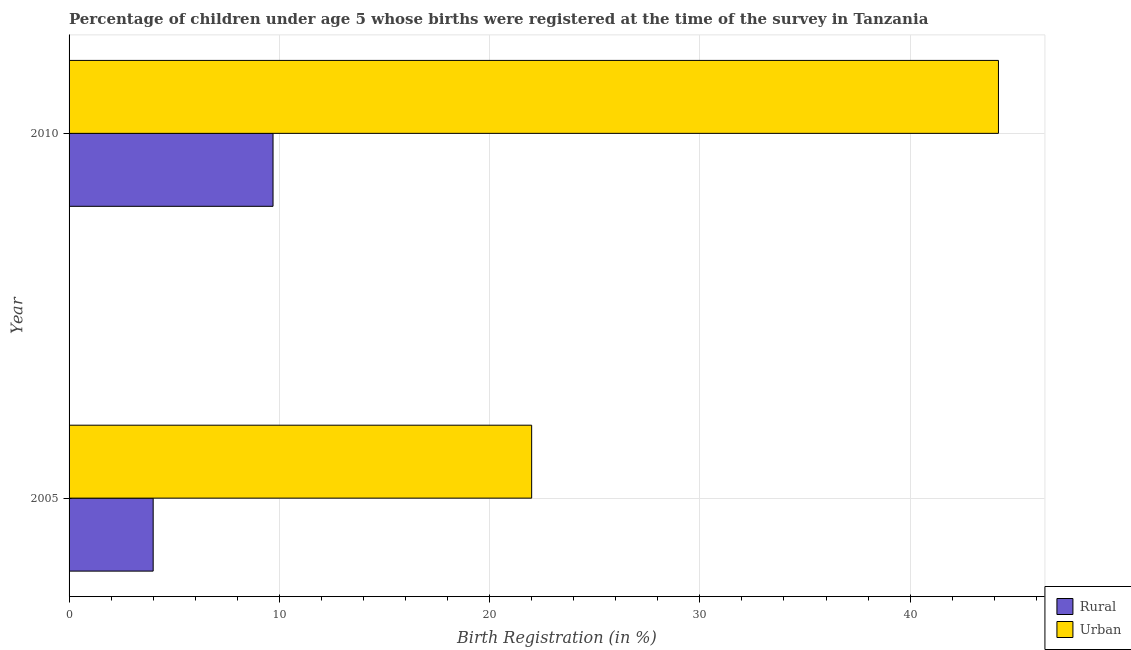How many bars are there on the 2nd tick from the bottom?
Your answer should be very brief. 2. In how many cases, is the number of bars for a given year not equal to the number of legend labels?
Make the answer very short. 0. What is the urban birth registration in 2005?
Your answer should be compact. 22. Across all years, what is the maximum urban birth registration?
Keep it short and to the point. 44.2. In which year was the rural birth registration maximum?
Offer a terse response. 2010. What is the total urban birth registration in the graph?
Your answer should be very brief. 66.2. What is the difference between the urban birth registration in 2005 and that in 2010?
Keep it short and to the point. -22.2. What is the difference between the urban birth registration in 2010 and the rural birth registration in 2005?
Your answer should be very brief. 40.2. What is the average rural birth registration per year?
Provide a short and direct response. 6.85. In the year 2010, what is the difference between the rural birth registration and urban birth registration?
Offer a terse response. -34.5. What is the ratio of the rural birth registration in 2005 to that in 2010?
Your response must be concise. 0.41. In how many years, is the urban birth registration greater than the average urban birth registration taken over all years?
Offer a very short reply. 1. What does the 2nd bar from the top in 2010 represents?
Offer a terse response. Rural. What does the 2nd bar from the bottom in 2005 represents?
Make the answer very short. Urban. What is the difference between two consecutive major ticks on the X-axis?
Offer a very short reply. 10. Does the graph contain any zero values?
Your answer should be compact. No. Where does the legend appear in the graph?
Keep it short and to the point. Bottom right. How many legend labels are there?
Provide a short and direct response. 2. How are the legend labels stacked?
Offer a terse response. Vertical. What is the title of the graph?
Your answer should be compact. Percentage of children under age 5 whose births were registered at the time of the survey in Tanzania. Does "Study and work" appear as one of the legend labels in the graph?
Make the answer very short. No. What is the label or title of the X-axis?
Provide a succinct answer. Birth Registration (in %). What is the Birth Registration (in %) of Rural in 2005?
Offer a terse response. 4. What is the Birth Registration (in %) of Urban in 2005?
Your response must be concise. 22. What is the Birth Registration (in %) of Rural in 2010?
Keep it short and to the point. 9.7. What is the Birth Registration (in %) in Urban in 2010?
Offer a terse response. 44.2. Across all years, what is the maximum Birth Registration (in %) of Urban?
Your response must be concise. 44.2. What is the total Birth Registration (in %) of Rural in the graph?
Offer a very short reply. 13.7. What is the total Birth Registration (in %) of Urban in the graph?
Keep it short and to the point. 66.2. What is the difference between the Birth Registration (in %) of Rural in 2005 and that in 2010?
Provide a succinct answer. -5.7. What is the difference between the Birth Registration (in %) in Urban in 2005 and that in 2010?
Your answer should be very brief. -22.2. What is the difference between the Birth Registration (in %) in Rural in 2005 and the Birth Registration (in %) in Urban in 2010?
Make the answer very short. -40.2. What is the average Birth Registration (in %) of Rural per year?
Your answer should be very brief. 6.85. What is the average Birth Registration (in %) of Urban per year?
Give a very brief answer. 33.1. In the year 2005, what is the difference between the Birth Registration (in %) in Rural and Birth Registration (in %) in Urban?
Give a very brief answer. -18. In the year 2010, what is the difference between the Birth Registration (in %) of Rural and Birth Registration (in %) of Urban?
Keep it short and to the point. -34.5. What is the ratio of the Birth Registration (in %) of Rural in 2005 to that in 2010?
Keep it short and to the point. 0.41. What is the ratio of the Birth Registration (in %) of Urban in 2005 to that in 2010?
Give a very brief answer. 0.5. What is the difference between the highest and the lowest Birth Registration (in %) of Rural?
Offer a very short reply. 5.7. What is the difference between the highest and the lowest Birth Registration (in %) in Urban?
Keep it short and to the point. 22.2. 